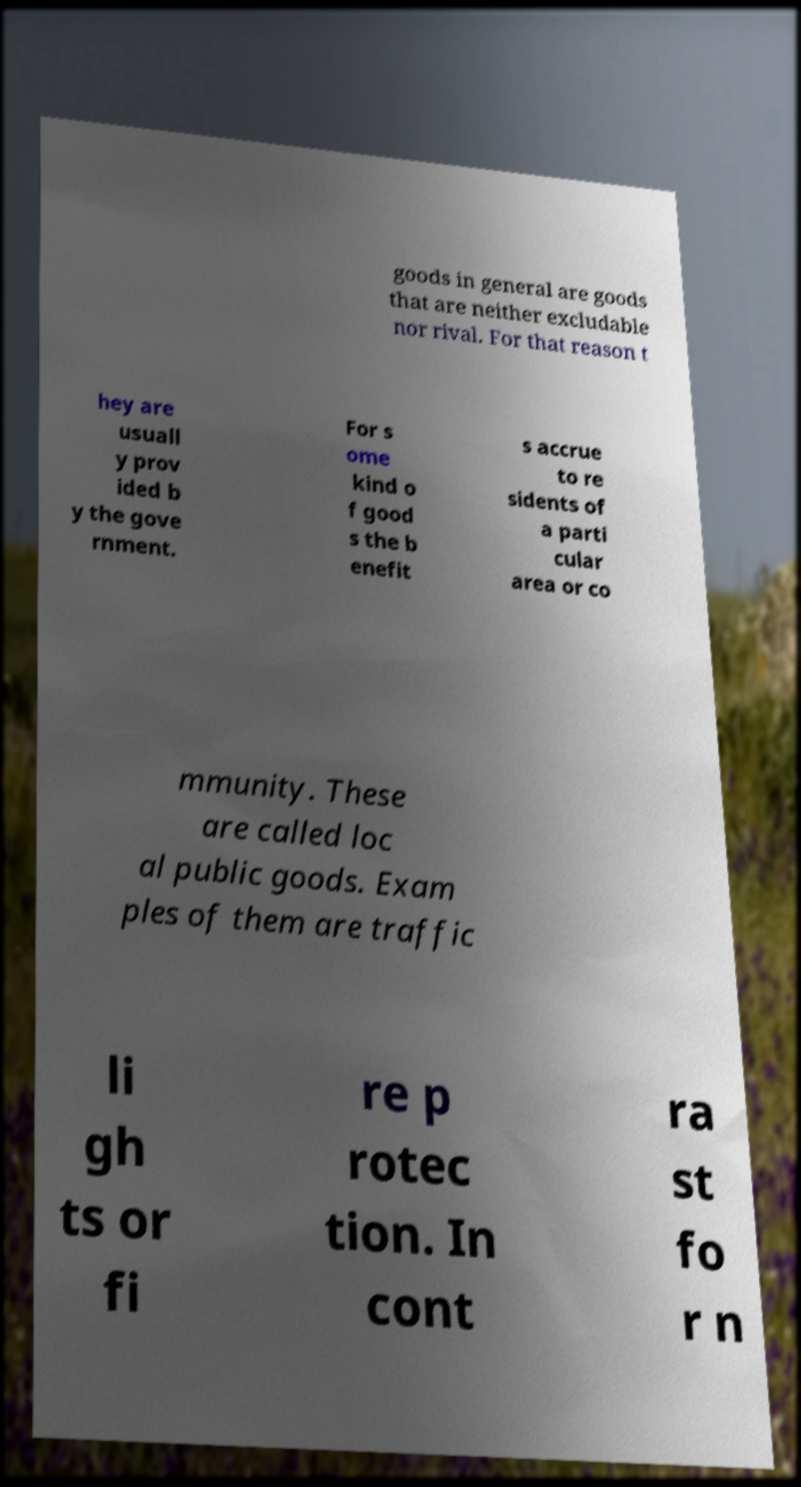There's text embedded in this image that I need extracted. Can you transcribe it verbatim? goods in general are goods that are neither excludable nor rival. For that reason t hey are usuall y prov ided b y the gove rnment. For s ome kind o f good s the b enefit s accrue to re sidents of a parti cular area or co mmunity. These are called loc al public goods. Exam ples of them are traffic li gh ts or fi re p rotec tion. In cont ra st fo r n 